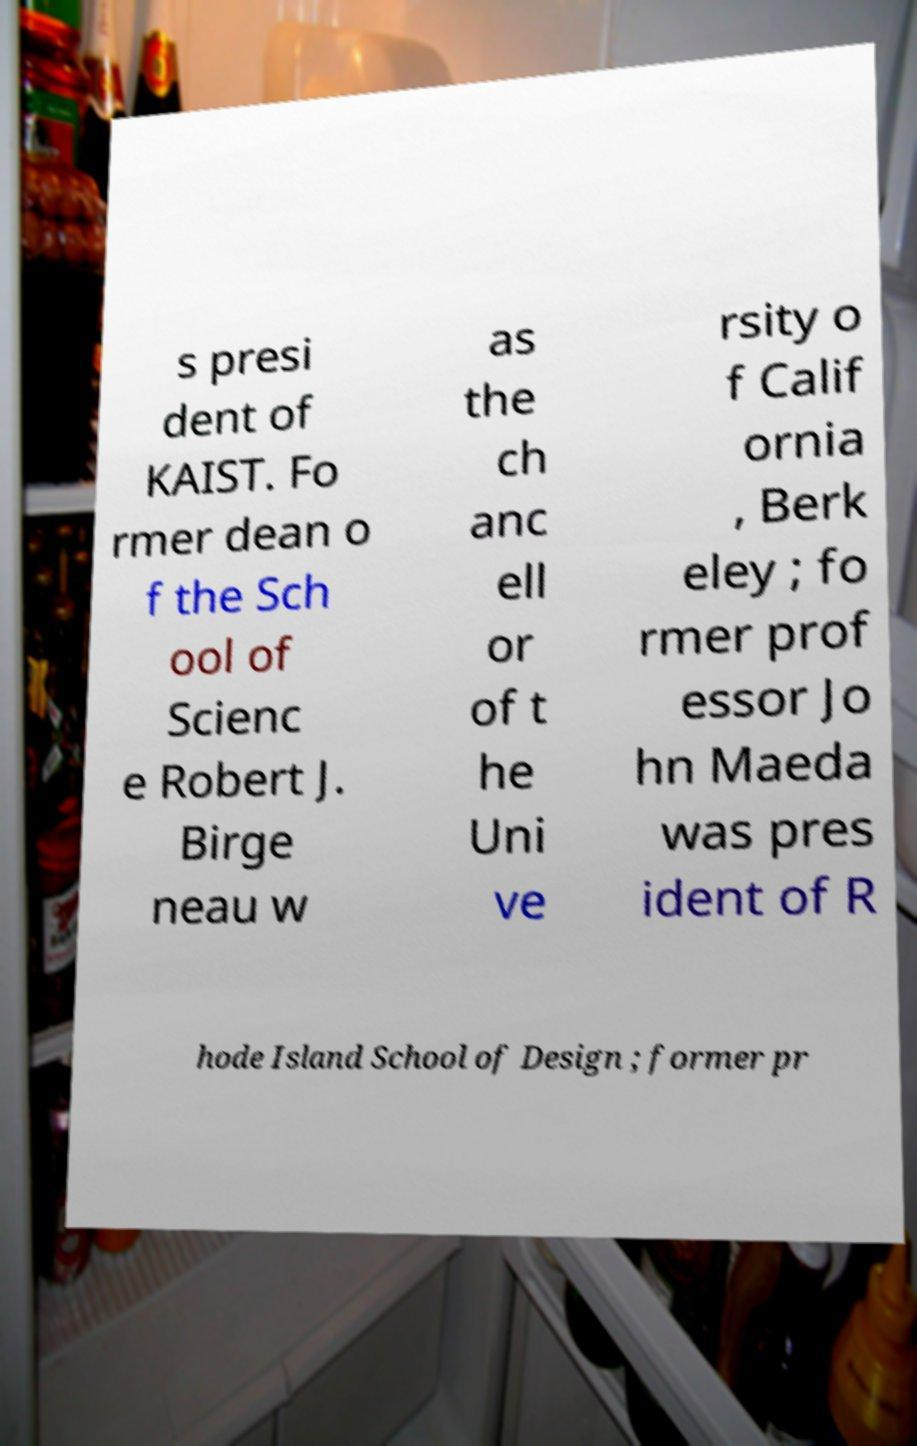Could you extract and type out the text from this image? s presi dent of KAIST. Fo rmer dean o f the Sch ool of Scienc e Robert J. Birge neau w as the ch anc ell or of t he Uni ve rsity o f Calif ornia , Berk eley ; fo rmer prof essor Jo hn Maeda was pres ident of R hode Island School of Design ; former pr 